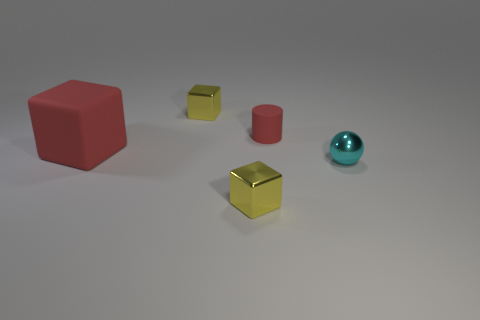Are there any other things that are the same size as the matte block?
Provide a short and direct response. No. There is a tiny metal thing in front of the small cyan metal sphere; is it the same shape as the large red matte thing?
Ensure brevity in your answer.  Yes. What is the shape of the tiny yellow shiny object that is on the left side of the small yellow shiny object that is in front of the metallic ball?
Give a very brief answer. Cube. There is a yellow thing that is behind the shiny block on the right side of the small cube that is behind the tiny cyan sphere; what is its size?
Give a very brief answer. Small. Is the metallic sphere the same size as the red rubber cylinder?
Offer a very short reply. Yes. There is a red object to the right of the big red rubber object; what is its material?
Give a very brief answer. Rubber. What number of other objects are there of the same shape as the large red thing?
Make the answer very short. 2. Are there any cubes behind the cyan metallic thing?
Make the answer very short. Yes. What number of things are gray blocks or tiny red objects?
Ensure brevity in your answer.  1. What number of other objects are the same size as the red rubber cube?
Make the answer very short. 0. 